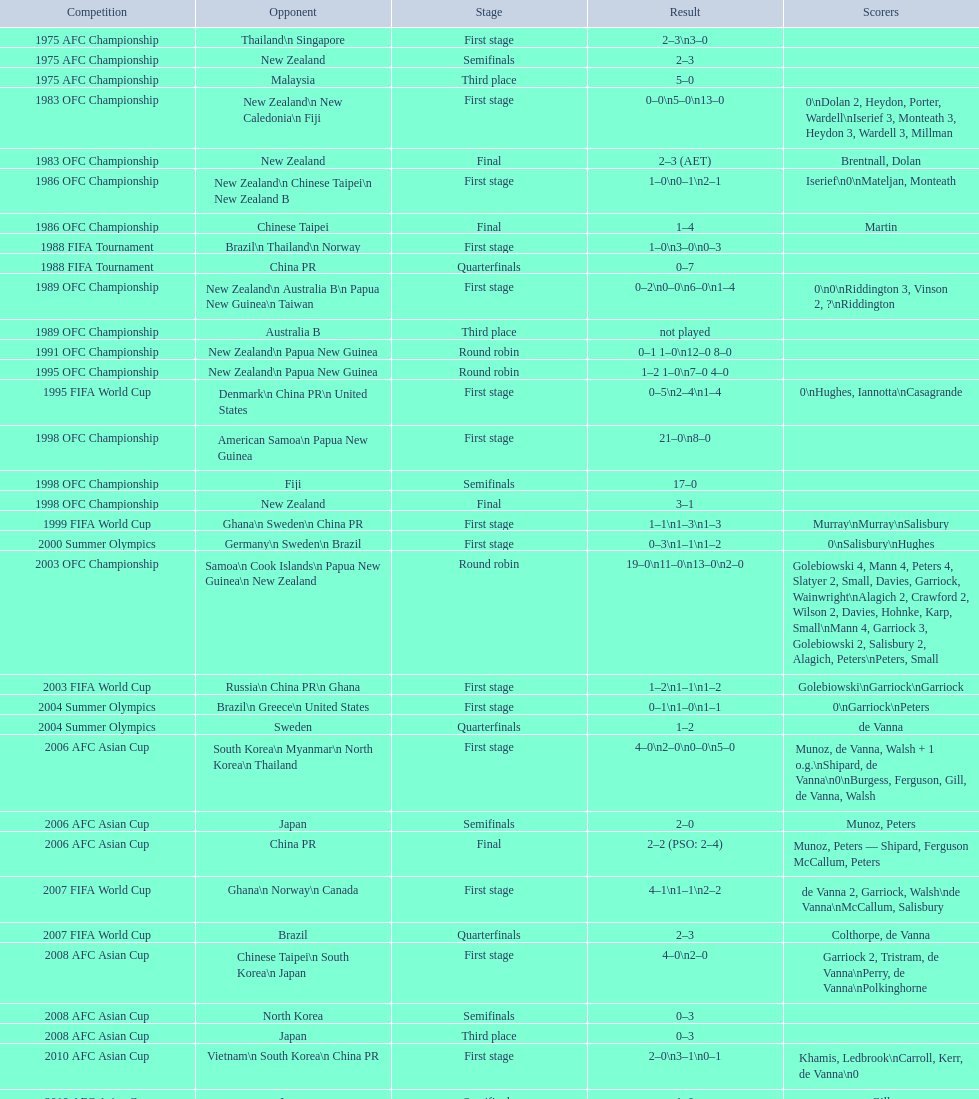How many points were scored in the final round of the 2012 summer olympics afc qualification? 12. 